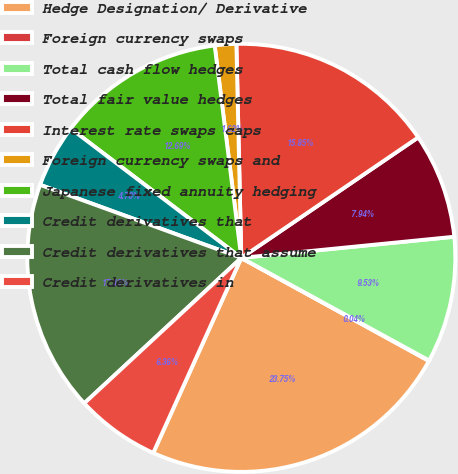<chart> <loc_0><loc_0><loc_500><loc_500><pie_chart><fcel>Hedge Designation/ Derivative<fcel>Foreign currency swaps<fcel>Total cash flow hedges<fcel>Total fair value hedges<fcel>Interest rate swaps caps<fcel>Foreign currency swaps and<fcel>Japanese fixed annuity hedging<fcel>Credit derivatives that<fcel>Credit derivatives that assume<fcel>Credit derivatives in<nl><fcel>23.75%<fcel>0.04%<fcel>9.53%<fcel>7.94%<fcel>15.85%<fcel>1.62%<fcel>12.69%<fcel>4.78%<fcel>17.43%<fcel>6.36%<nl></chart> 